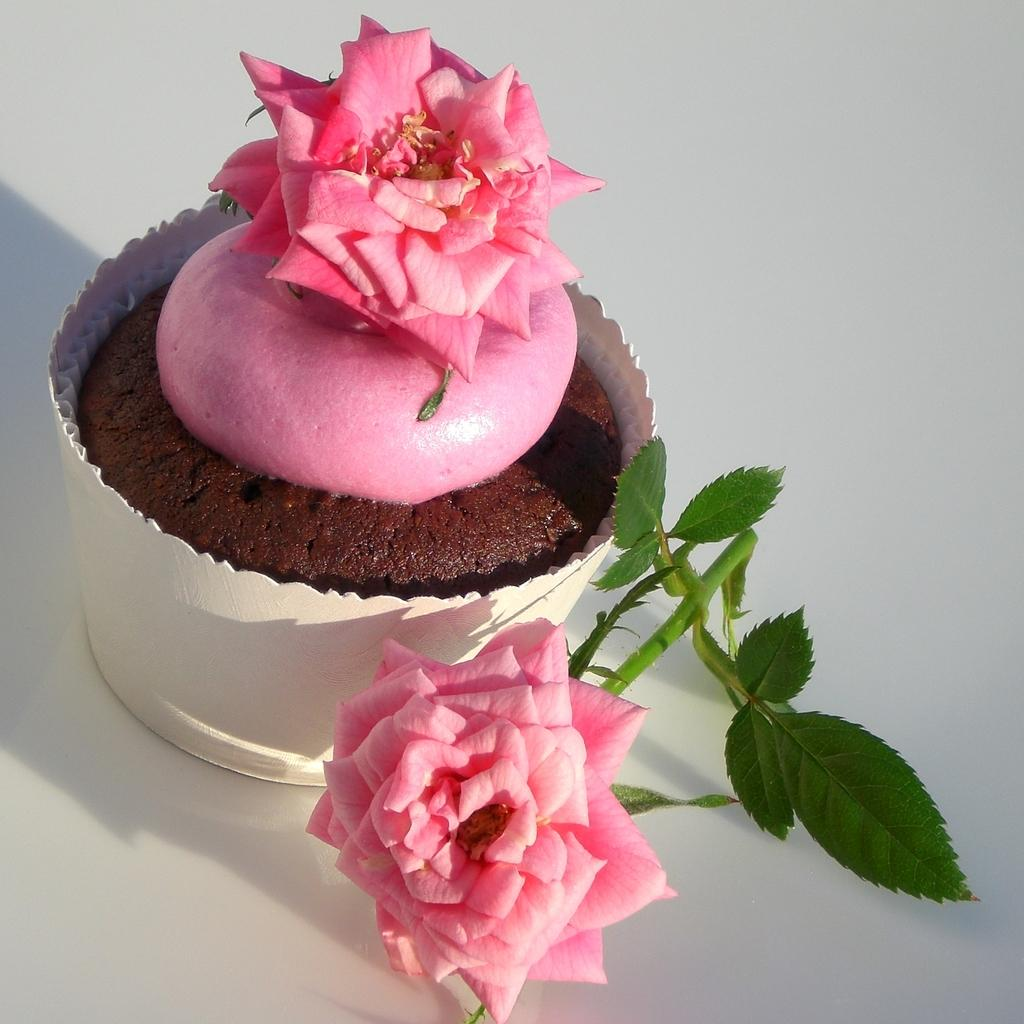How many flowers are visible in the image? There are two flowers in the image. What else can be seen in the image besides the flowers? There are plants in the image. Where are the plants and flowers located? The plants and flowers are in a pot. What is the color of the surface on which the pot and plants are placed? The pot and the plants are on a white colored surface. Reasoning: Let's think step by following the guidelines to produce the conversation. We start by identifying the main subjects in the image, which are the flowers and plants. Then, we describe their location and the presence of the pot. Finally, we mention the color of the surface on which the pot and plants are placed. Each question is designed to elicit a specific detail about the image that is known from the provided facts. Absurd Question/Answer: What type of thread is being used to smash the flowers in the image? There is no thread or smashing of flowers present in the image. 